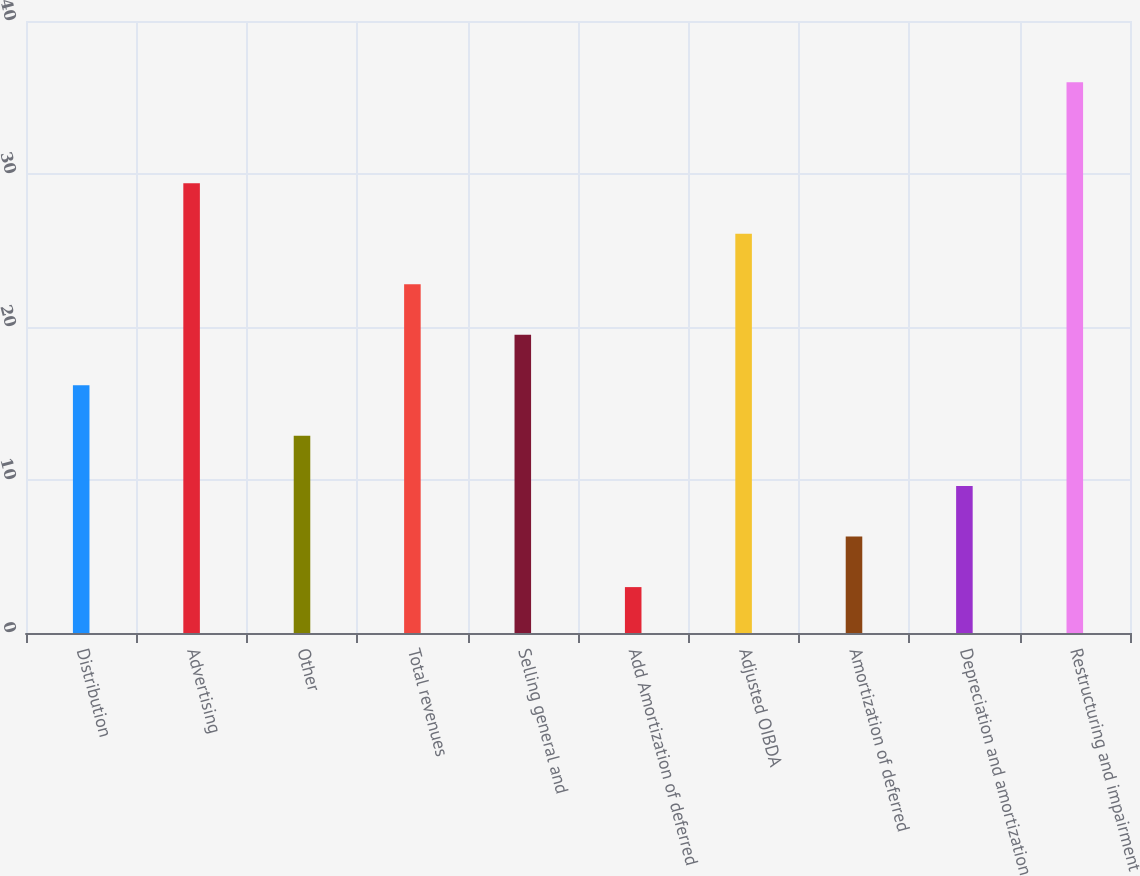<chart> <loc_0><loc_0><loc_500><loc_500><bar_chart><fcel>Distribution<fcel>Advertising<fcel>Other<fcel>Total revenues<fcel>Selling general and<fcel>Add Amortization of deferred<fcel>Adjusted OIBDA<fcel>Amortization of deferred<fcel>Depreciation and amortization<fcel>Restructuring and impairment<nl><fcel>16.2<fcel>29.4<fcel>12.9<fcel>22.8<fcel>19.5<fcel>3<fcel>26.1<fcel>6.3<fcel>9.6<fcel>36<nl></chart> 